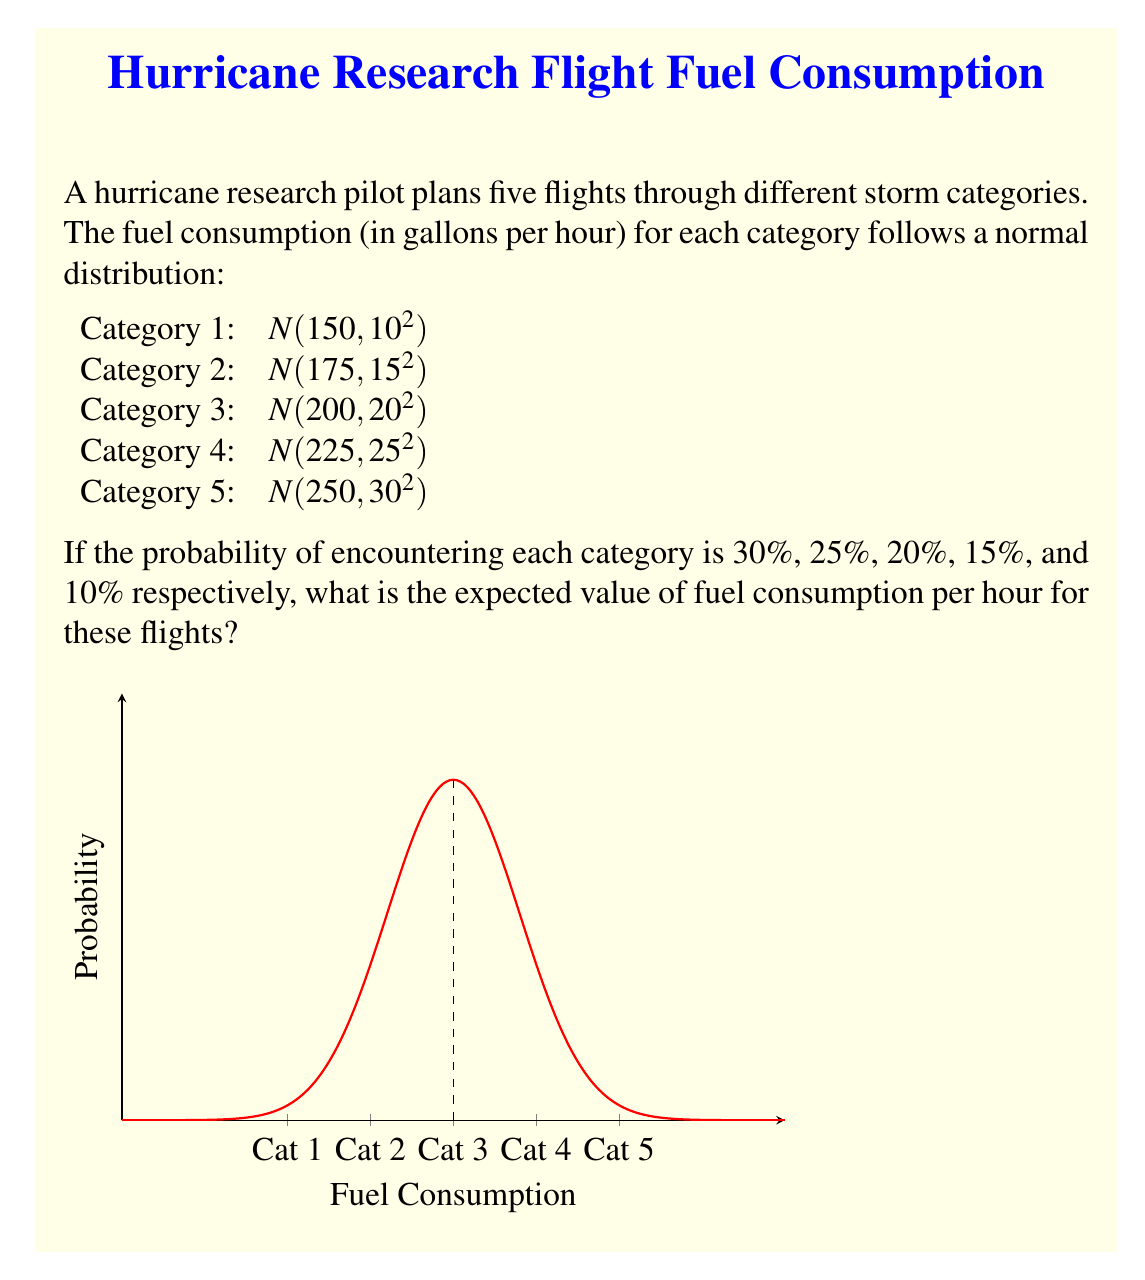Can you answer this question? To calculate the expected value, we need to:
1. Identify the mean fuel consumption for each category
2. Multiply each mean by its probability
3. Sum the results

Let's go through this step-by-step:

1. Mean fuel consumption for each category:
   Category 1: 150 gallons/hour
   Category 2: 175 gallons/hour
   Category 3: 200 gallons/hour
   Category 4: 225 gallons/hour
   Category 5: 250 gallons/hour

2. Multiply each mean by its probability:
   Category 1: $150 \times 0.30 = 45$ gallons/hour
   Category 2: $175 \times 0.25 = 43.75$ gallons/hour
   Category 3: $200 \times 0.20 = 40$ gallons/hour
   Category 4: $225 \times 0.15 = 33.75$ gallons/hour
   Category 5: $250 \times 0.10 = 25$ gallons/hour

3. Sum the results:
   $E(\text{Fuel Consumption}) = 45 + 43.75 + 40 + 33.75 + 25 = 187.5$ gallons/hour

Therefore, the expected value of fuel consumption per hour for these flights is 187.5 gallons.

Note: The standard deviations provided in the question do not affect the expected value calculation, but they would be relevant for other statistical analyses.
Answer: $187.5$ gallons/hour 